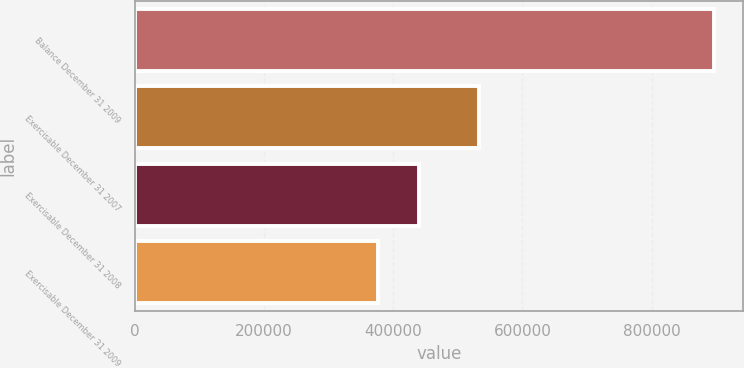Convert chart to OTSL. <chart><loc_0><loc_0><loc_500><loc_500><bar_chart><fcel>Balance December 31 2009<fcel>Exercisable December 31 2007<fcel>Exercisable December 31 2008<fcel>Exercisable December 31 2009<nl><fcel>896830<fcel>532750<fcel>440080<fcel>376450<nl></chart> 